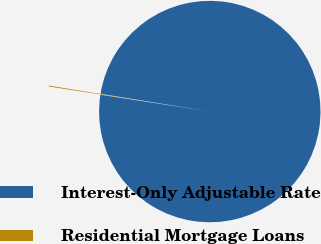<chart> <loc_0><loc_0><loc_500><loc_500><pie_chart><fcel>Interest-Only Adjustable Rate<fcel>Residential Mortgage Loans<nl><fcel>99.87%<fcel>0.13%<nl></chart> 